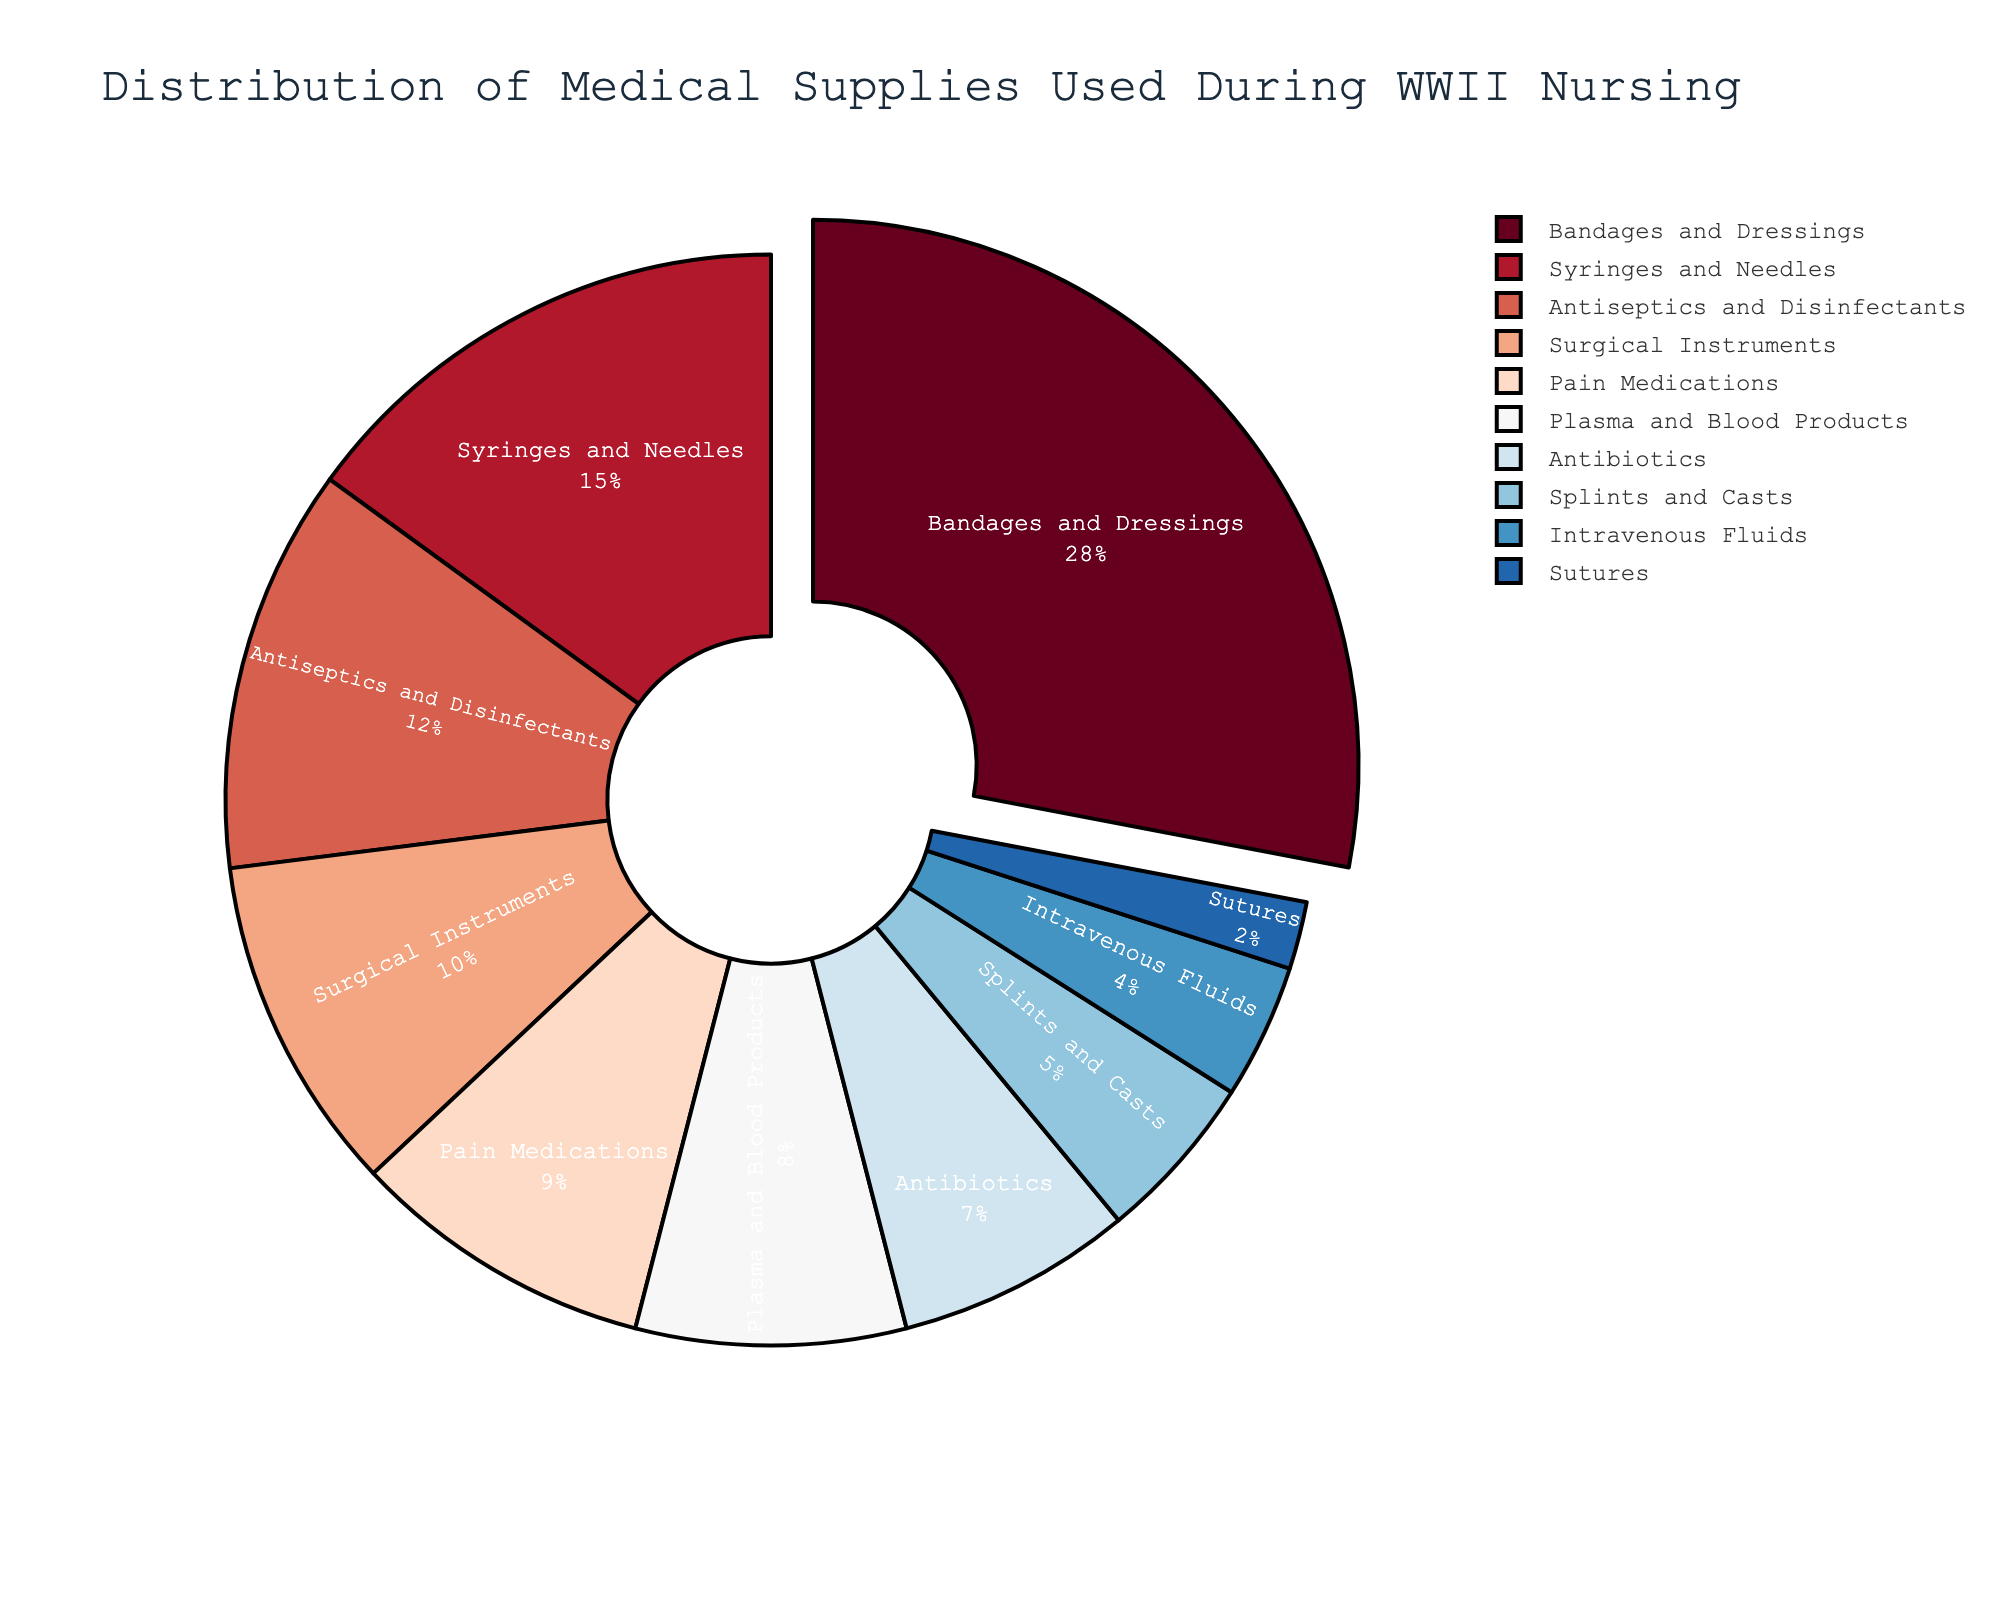Which category of medical supplies has the largest percentage? The largest portion of the pie chart is occupied by Bandages and Dressings, which has a percentage of 28%.
Answer: Bandages and Dressings Which category has the smallest percentage, and what is it? The smallest portion of the pie chart is Sutures, which occupies 2%.
Answer: Sutures, 2% What is the total percentage of Bandages and Dressings combined with Syringes and Needles? Add the percentages of Bandages and Dressings (28%) and Syringes and Needles (15%). 28 + 15 = 43.
Answer: 43% How does the percentage of Antiseptics and Disinfectants compare to Pain Medications? Antiseptics and Disinfectants have a higher percentage (12%) than Pain Medications (9%).
Answer: Antiseptics and Disinfectants are higher Which two categories are closest in percentage? The two categories closest in percentage are Plasma and Blood Products (8%) and Antibiotics (7%), with only a 1% difference.
Answer: Plasma and Blood Products, Antibiotics What is the combined percentage of Surgical Instruments, Splints and Casts, and Sutures? Add the percentages of Surgical Instruments (10%), Splints and Casts (5%), and Sutures (2%). 10 + 5 + 2 = 17.
Answer: 17% Are there more categories with a percentage greater than 10% or less than 5%? There are four categories with percentages over 10%: Bandages and Dressings (28%), Syringes and Needles (15%), Antiseptics and Disinfectants (12%), and Surgical Instruments (10%). Only two categories are under 5%: Intravenous Fluids (4%) and Sutures (2%).
Answer: More categories > 10% Which medical supply category that has 9% of the pie chart? The category with 9% is Pain Medications as indicated directly on the chart.
Answer: Pain Medications How much more is the percentage for Bandages and Dressings as compared to Antibiotics? Subtract the percentage of Antibiotics (7%) from Bandages and Dressings (28%). 28 - 7 = 21.
Answer: 21% Which color is used for Antiseptics and Disinfectants in the pie chart? Antiseptics and Disinfectants are colored using a hue from the sequential color scale, specifically a deeper shade of red from RdBu.
Answer: A deep red shade 